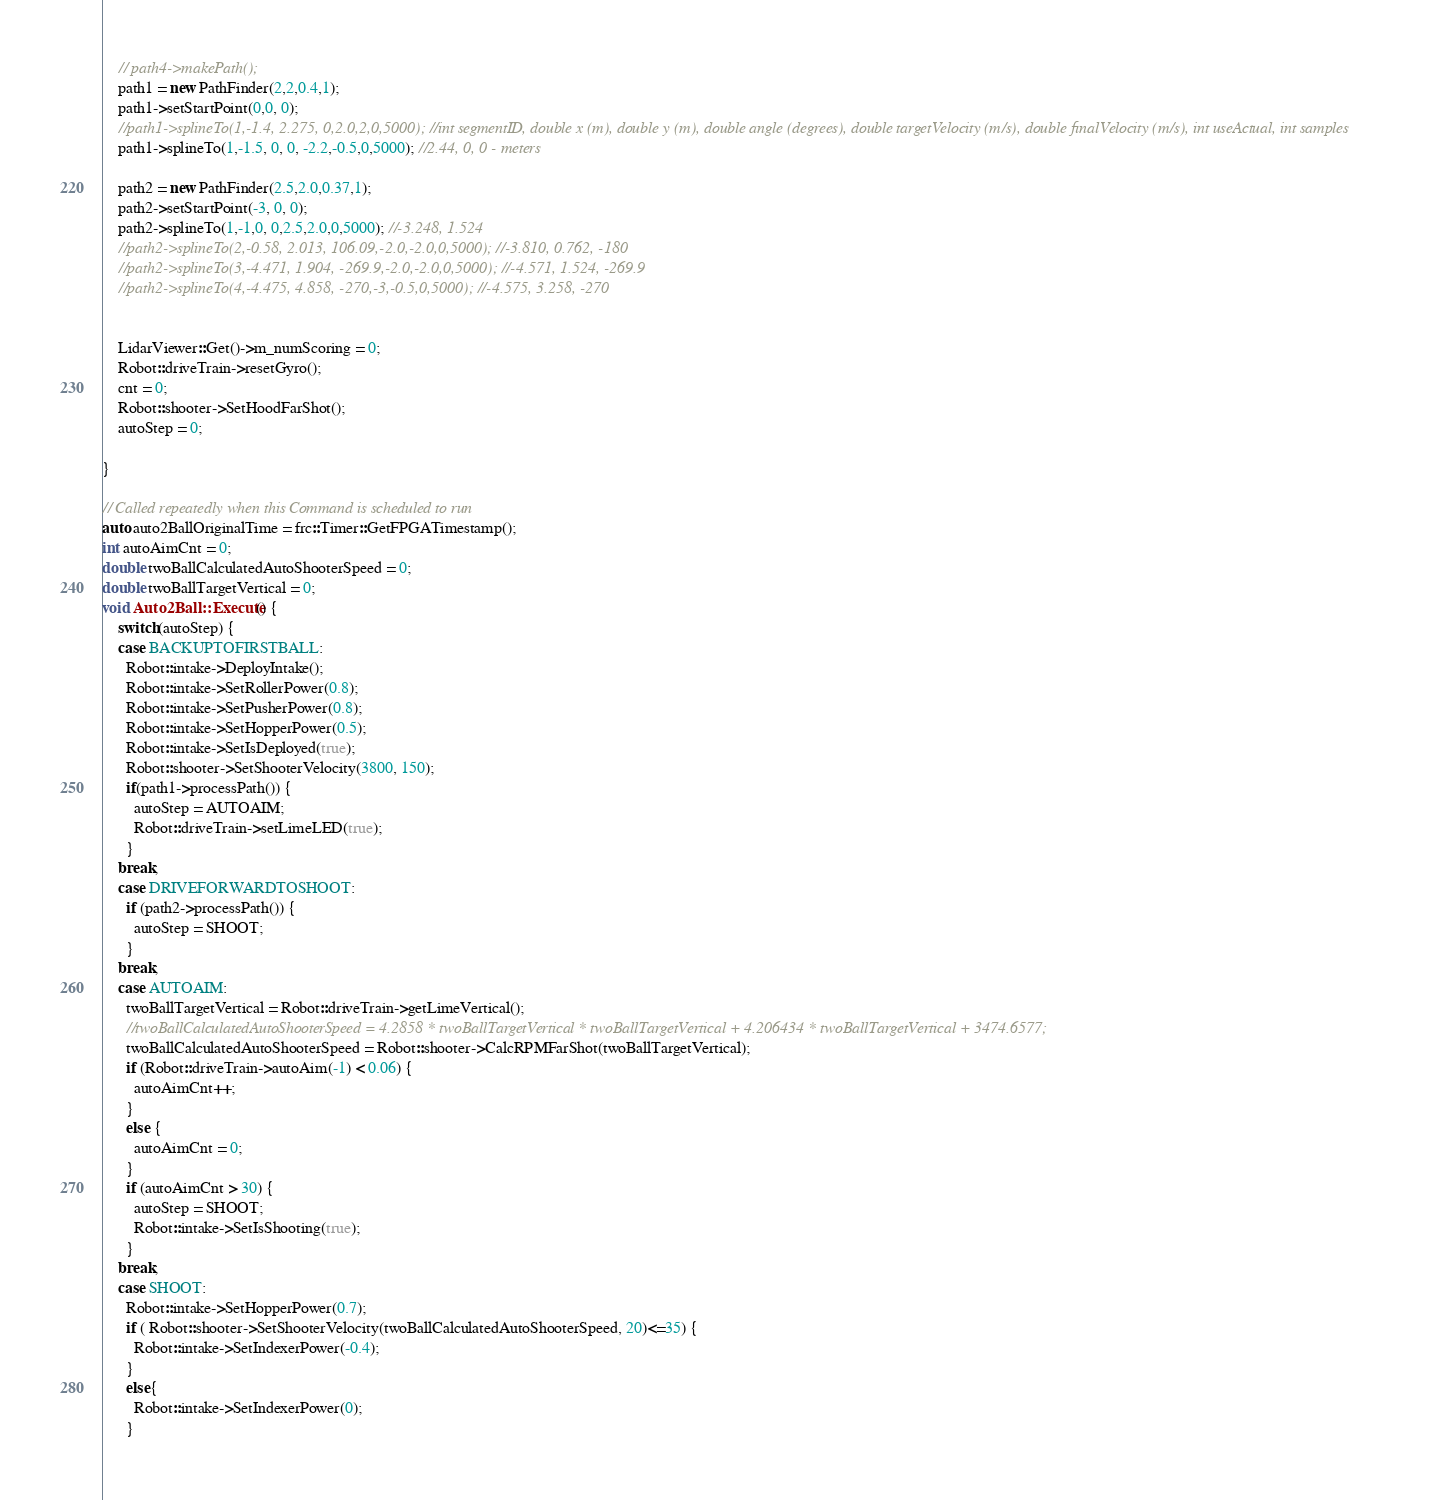<code> <loc_0><loc_0><loc_500><loc_500><_C++_>    // path4->makePath();
    path1 = new PathFinder(2,2,0.4,1);
    path1->setStartPoint(0,0, 0); 
    //path1->splineTo(1,-1.4, 2.275, 0,2.0,2,0,5000); //int segmentID, double x (m), double y (m), double angle (degrees), double targetVelocity (m/s), double finalVelocity (m/s), int useActual, int samples
    path1->splineTo(1,-1.5, 0, 0, -2.2,-0.5,0,5000); //2.44, 0, 0 - meters

    path2 = new PathFinder(2.5,2.0,0.37,1);
    path2->setStartPoint(-3, 0, 0); 
    path2->splineTo(1,-1,0, 0,2.5,2.0,0,5000); //-3.248, 1.524
    //path2->splineTo(2,-0.58, 2.013, 106.09,-2.0,-2.0,0,5000); //-3.810, 0.762, -180
    //path2->splineTo(3,-4.471, 1.904, -269.9,-2.0,-2.0,0,5000); //-4.571, 1.524, -269.9
    //path2->splineTo(4,-4.475, 4.858, -270,-3,-0.5,0,5000); //-4.575, 3.258, -270

    
    LidarViewer::Get()->m_numScoring = 0;
    Robot::driveTrain->resetGyro();
    cnt = 0;
    Robot::shooter->SetHoodFarShot();
    autoStep = 0;

}

// Called repeatedly when this Command is scheduled to run
auto auto2BallOriginalTime = frc::Timer::GetFPGATimestamp();
int autoAimCnt = 0;
double twoBallCalculatedAutoShooterSpeed = 0;
double twoBallTargetVertical = 0;
void Auto2Ball::Execute() {
    switch(autoStep) {
    case BACKUPTOFIRSTBALL:
      Robot::intake->DeployIntake();
      Robot::intake->SetRollerPower(0.8);
      Robot::intake->SetPusherPower(0.8);
      Robot::intake->SetHopperPower(0.5);
      Robot::intake->SetIsDeployed(true);
      Robot::shooter->SetShooterVelocity(3800, 150);
      if(path1->processPath()) {
        autoStep = AUTOAIM;
        Robot::driveTrain->setLimeLED(true);
      }
    break;
    case DRIVEFORWARDTOSHOOT:
      if (path2->processPath()) {
        autoStep = SHOOT;
      }
    break;
    case AUTOAIM:
      twoBallTargetVertical = Robot::driveTrain->getLimeVertical();
      //twoBallCalculatedAutoShooterSpeed = 4.2858 * twoBallTargetVertical * twoBallTargetVertical + 4.206434 * twoBallTargetVertical + 3474.6577;
      twoBallCalculatedAutoShooterSpeed = Robot::shooter->CalcRPMFarShot(twoBallTargetVertical);
      if (Robot::driveTrain->autoAim(-1) < 0.06) {
        autoAimCnt++;
      }
      else {
        autoAimCnt = 0;
      }
      if (autoAimCnt > 30) {
        autoStep = SHOOT;
        Robot::intake->SetIsShooting(true);
      }
    break;
    case SHOOT:
      Robot::intake->SetHopperPower(0.7);
      if ( Robot::shooter->SetShooterVelocity(twoBallCalculatedAutoShooterSpeed, 20)<=35) {
        Robot::intake->SetIndexerPower(-0.4);
      }
      else{
        Robot::intake->SetIndexerPower(0);
      }</code> 